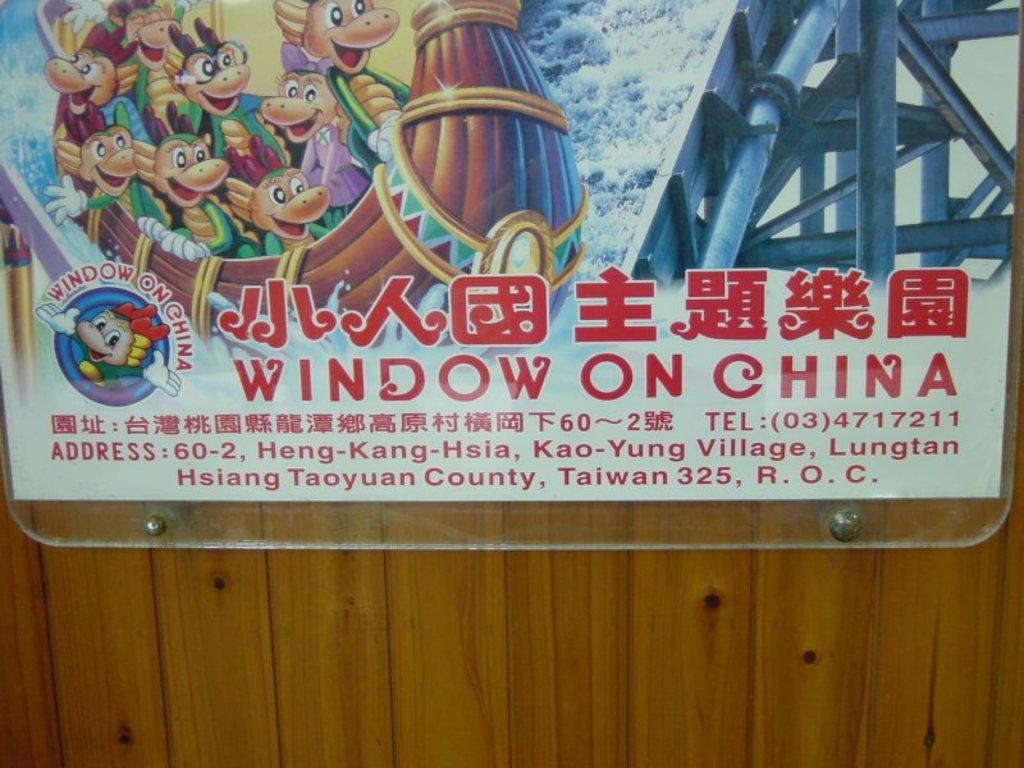Provide a one-sentence caption for the provided image. A poster hung on a wall advertises Window On China. 